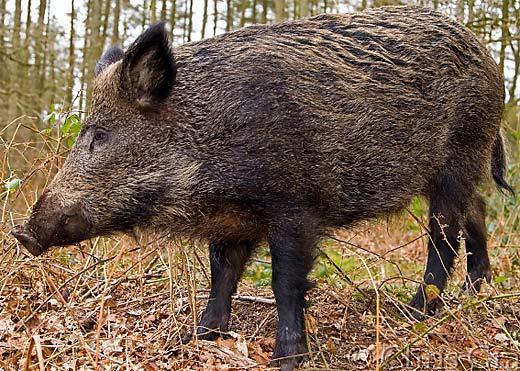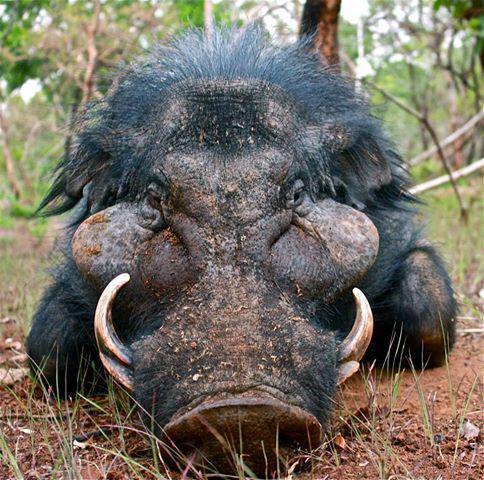The first image is the image on the left, the second image is the image on the right. For the images displayed, is the sentence "There are at least two baby boars in one of the images." factually correct? Answer yes or no. No. 